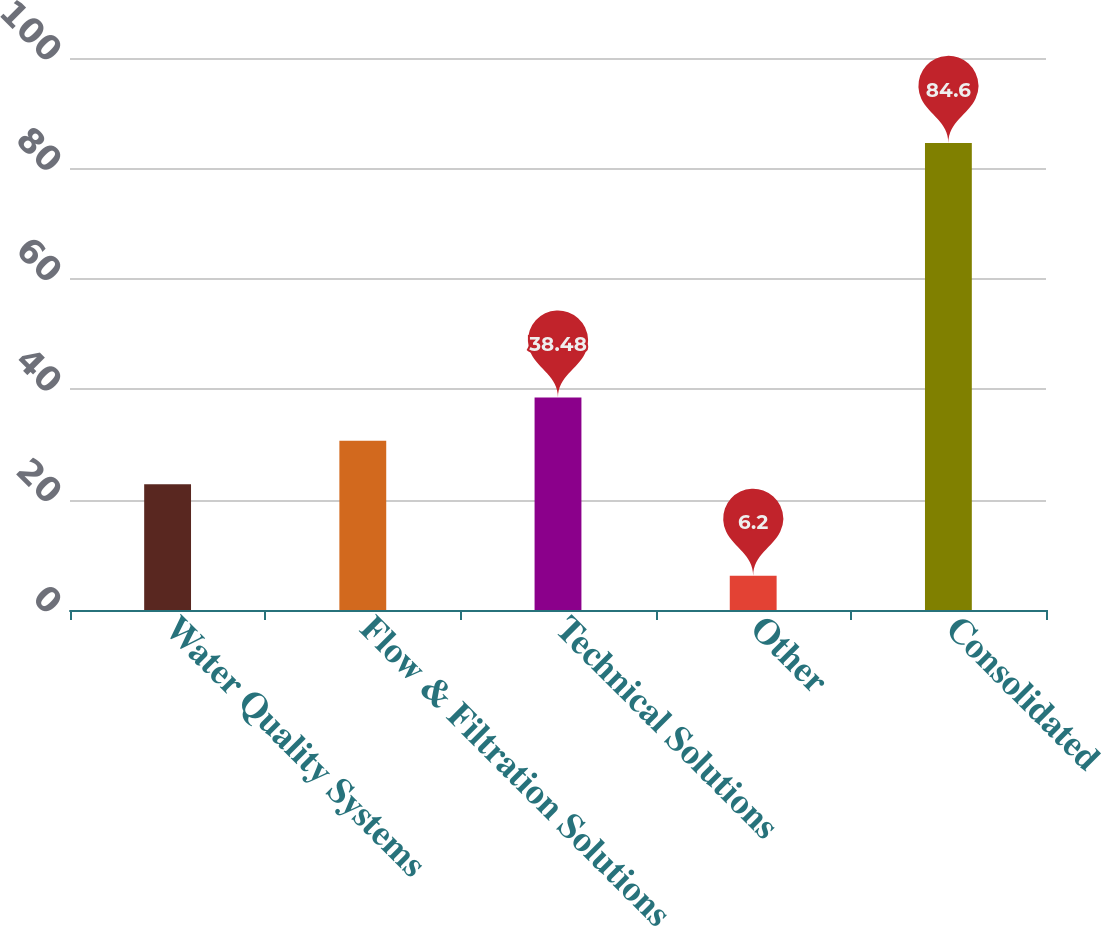Convert chart to OTSL. <chart><loc_0><loc_0><loc_500><loc_500><bar_chart><fcel>Water Quality Systems<fcel>Flow & Filtration Solutions<fcel>Technical Solutions<fcel>Other<fcel>Consolidated<nl><fcel>22.8<fcel>30.64<fcel>38.48<fcel>6.2<fcel>84.6<nl></chart> 